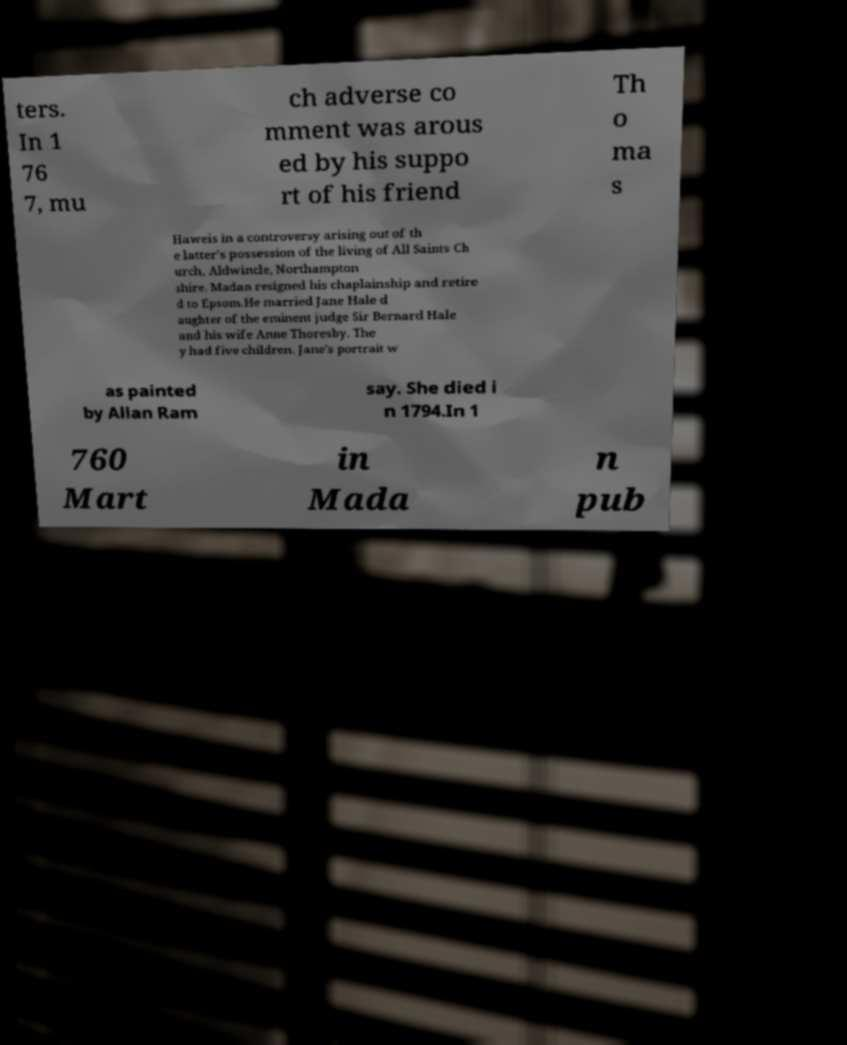I need the written content from this picture converted into text. Can you do that? ters. In 1 76 7, mu ch adverse co mment was arous ed by his suppo rt of his friend Th o ma s Haweis in a controversy arising out of th e latter's possession of the living of All Saints Ch urch, Aldwincle, Northampton shire. Madan resigned his chaplainship and retire d to Epsom.He married Jane Hale d aughter of the eminent judge Sir Bernard Hale and his wife Anne Thoresby. The y had five children. Jane's portrait w as painted by Allan Ram say. She died i n 1794.In 1 760 Mart in Mada n pub 